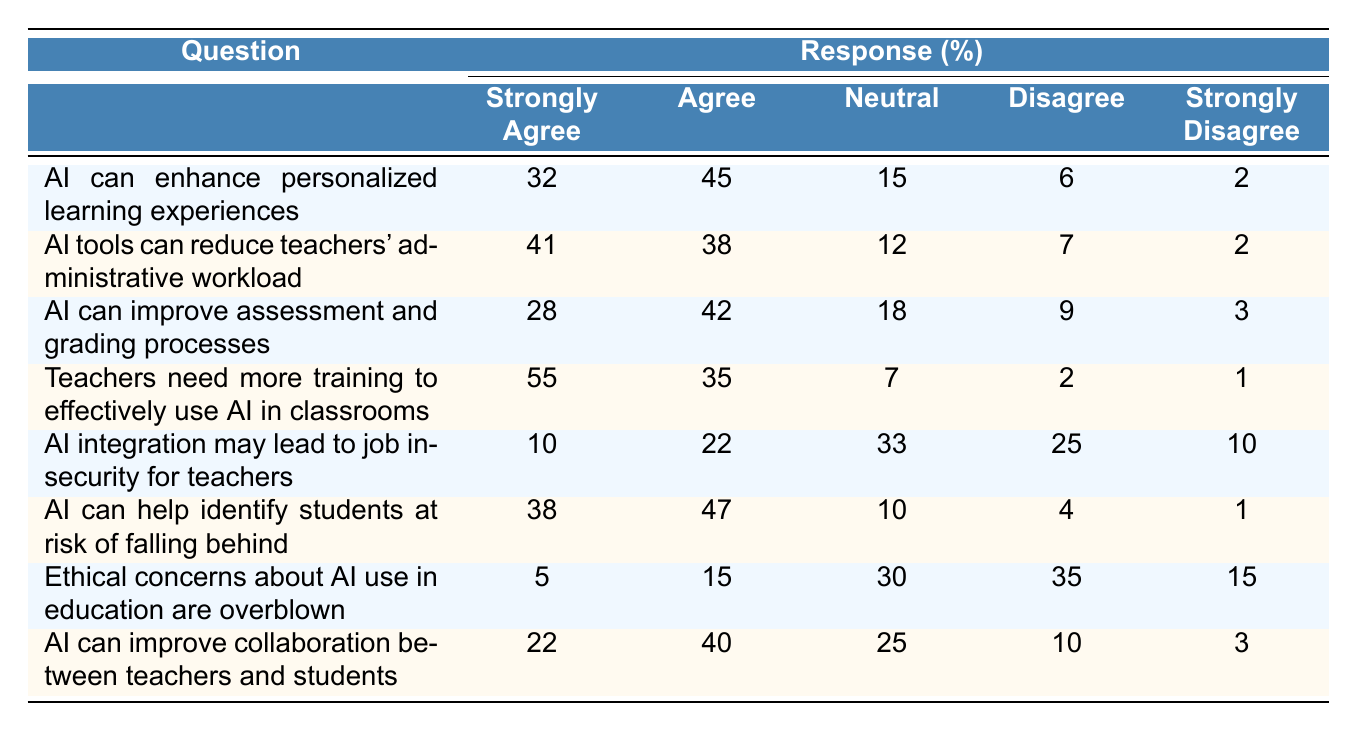What percentage of teachers strongly agree that AI can enhance personalized learning experiences? The table indicates that 32% of teachers responded with "Strongly Agree" to the question about AI enhancing personalized learning experiences.
Answer: 32% How many teachers agree or strongly agree that AI tools can reduce administrative workload? The data shows that 41% strongly agree and 38% agree, giving a total of 41 + 38 = 79%.
Answer: 79% What is the percentage of teachers who are neutral about the idea that AI can improve assessment and grading processes? The table displays that 18% of teachers selected "Neutral" for the AI assessment question, which directly answers the question.
Answer: 18% Is it true that more teachers believe AI integration may lead to job insecurity compared to those who believe it will not? The sum of those who disagree (25%) and strongly disagree (10%) is 35%, which is greater than the sum of those who agree (22%) and strongly agree (10%), totaling 32%.
Answer: Yes What percentage of teachers agree that ethical concerns about AI in education are overblown? According to the table, only 15% agree while 35% disagree, indicating that the majority of teachers do not think ethical concerns are overblown.
Answer: 15% What is the strongest consensus among teachers regarding the need for training to effectively use AI in classrooms? The strongest consensus is indicated by the percentage of teachers who strongly agree (55%) compared to all other responses, clearly showing a significant majority support for training.
Answer: 55% How many more teachers strongly agree that AI can help identify at-risk students compared to those who strongly disagree? The difference between those who strongly agree (38%) and those who strongly disagree (1%) is 38 - 1 = 37%.
Answer: 37% If we average the percentage of teachers who agree or strongly agree with all AI-related statements, what would that value be? The percentages for "Strongly Agree" and "Agree" together for each question totals to (32 + 45 + 41 + 38 + 28 + 42 + 55 + 40) = 321. There are 8 questions, so the average is 321 / 8 = 40.125, which rounds to 40%.
Answer: 40% Which question received the highest percentage of "Strongly Agree" responses? The question about needing more training received the highest "Strongly Agree" response at 55%.
Answer: Teachers need more training to effectively use AI in classrooms What is the total percentage of negative responses (Disagree and Strongly Disagree) regarding AI integration security concerns? The total percentage of negative responses is 25% (Disagree) + 10% (Strongly Disagree) = 35%.
Answer: 35% 